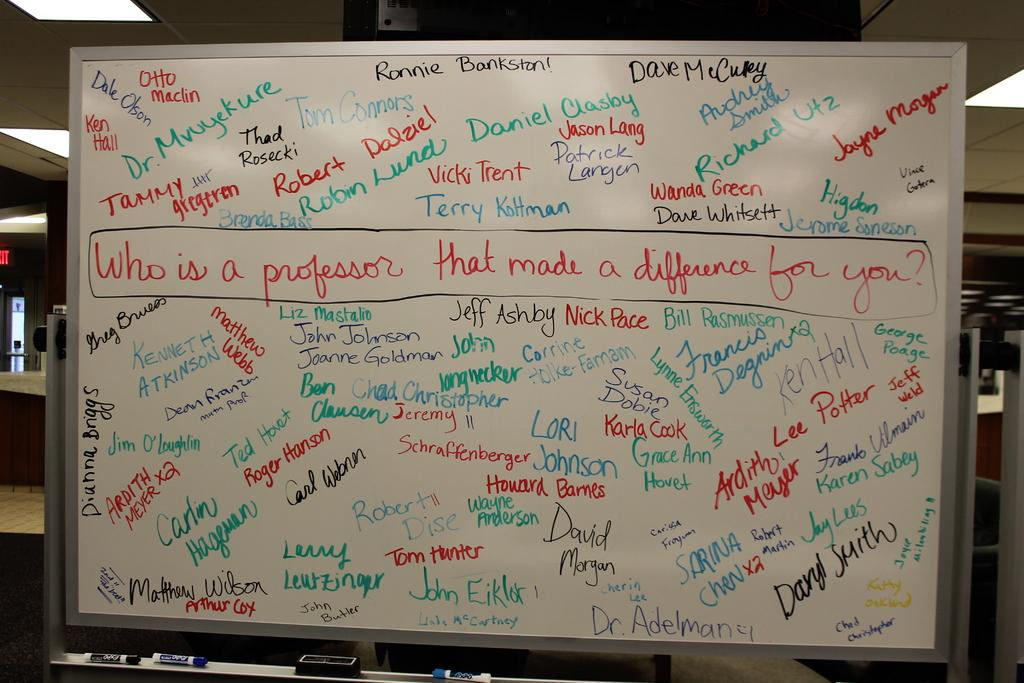Provide a one-sentence caption for the provided image. a white board with names and asking Who is a professor. 